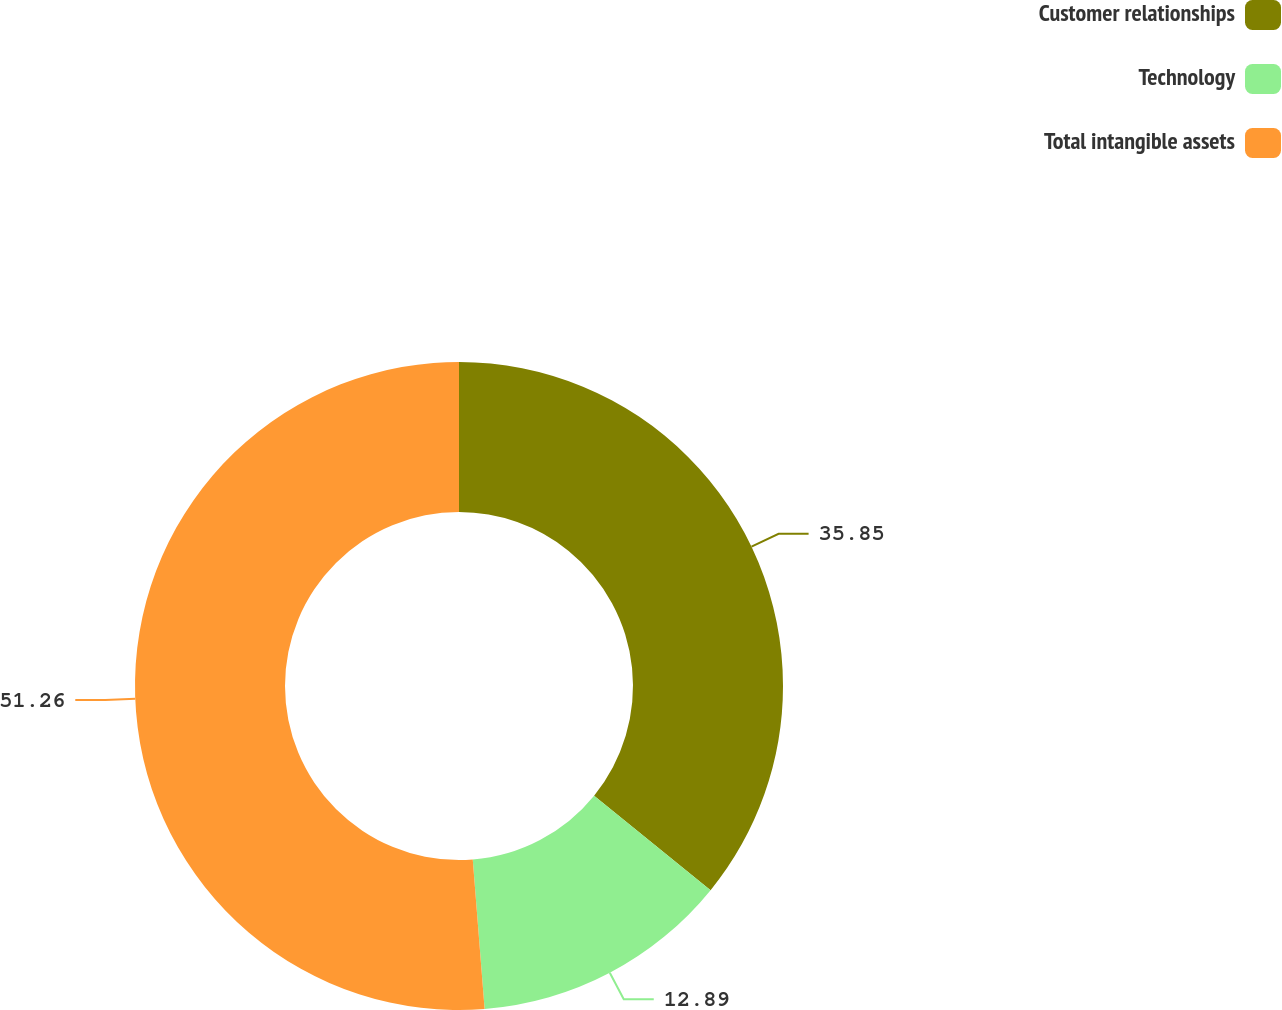Convert chart to OTSL. <chart><loc_0><loc_0><loc_500><loc_500><pie_chart><fcel>Customer relationships<fcel>Technology<fcel>Total intangible assets<nl><fcel>35.85%<fcel>12.89%<fcel>51.26%<nl></chart> 